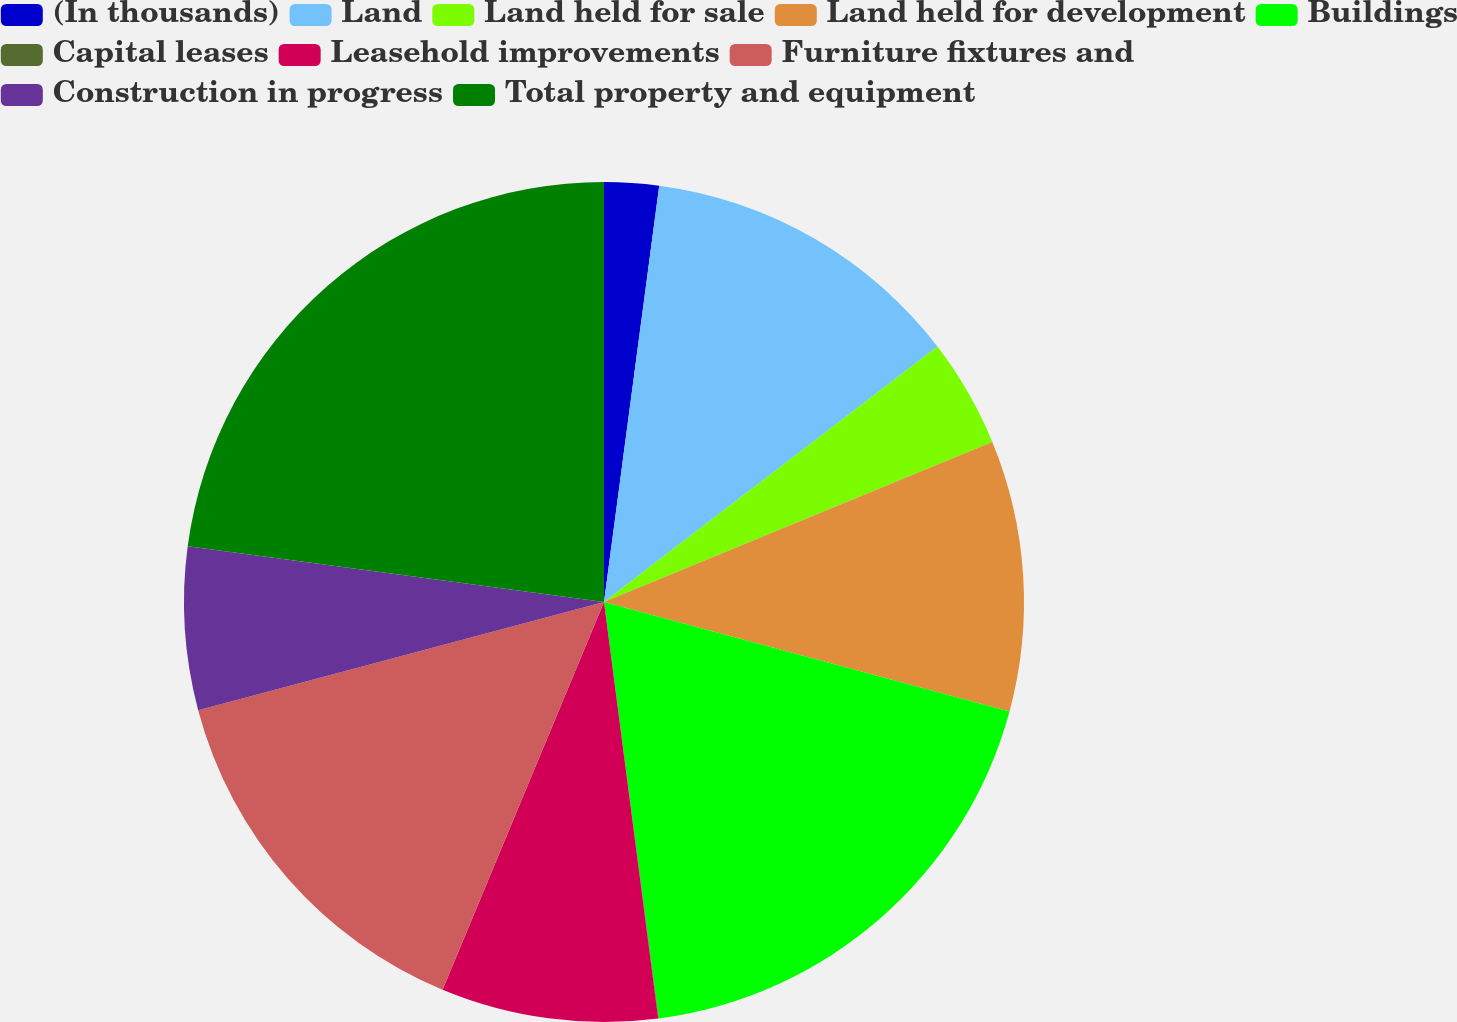Convert chart. <chart><loc_0><loc_0><loc_500><loc_500><pie_chart><fcel>(In thousands)<fcel>Land<fcel>Land held for sale<fcel>Land held for development<fcel>Buildings<fcel>Capital leases<fcel>Leasehold improvements<fcel>Furniture fixtures and<fcel>Construction in progress<fcel>Total property and equipment<nl><fcel>2.1%<fcel>12.5%<fcel>4.18%<fcel>10.42%<fcel>18.73%<fcel>0.02%<fcel>8.34%<fcel>14.58%<fcel>6.26%<fcel>22.89%<nl></chart> 